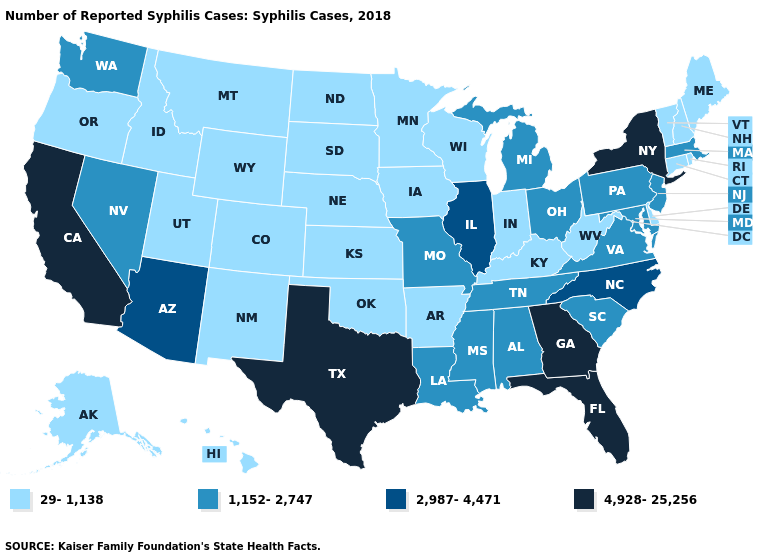Name the states that have a value in the range 1,152-2,747?
Answer briefly. Alabama, Louisiana, Maryland, Massachusetts, Michigan, Mississippi, Missouri, Nevada, New Jersey, Ohio, Pennsylvania, South Carolina, Tennessee, Virginia, Washington. What is the value of Rhode Island?
Answer briefly. 29-1,138. Does Indiana have the lowest value in the MidWest?
Write a very short answer. Yes. What is the value of Louisiana?
Be succinct. 1,152-2,747. Is the legend a continuous bar?
Answer briefly. No. Which states have the lowest value in the USA?
Short answer required. Alaska, Arkansas, Colorado, Connecticut, Delaware, Hawaii, Idaho, Indiana, Iowa, Kansas, Kentucky, Maine, Minnesota, Montana, Nebraska, New Hampshire, New Mexico, North Dakota, Oklahoma, Oregon, Rhode Island, South Dakota, Utah, Vermont, West Virginia, Wisconsin, Wyoming. Among the states that border Idaho , does Nevada have the highest value?
Quick response, please. Yes. Does Arizona have a lower value than Wisconsin?
Quick response, please. No. Does North Carolina have the same value as New Mexico?
Answer briefly. No. Does the first symbol in the legend represent the smallest category?
Give a very brief answer. Yes. What is the highest value in the USA?
Quick response, please. 4,928-25,256. Among the states that border New York , which have the lowest value?
Answer briefly. Connecticut, Vermont. What is the value of New Jersey?
Answer briefly. 1,152-2,747. 